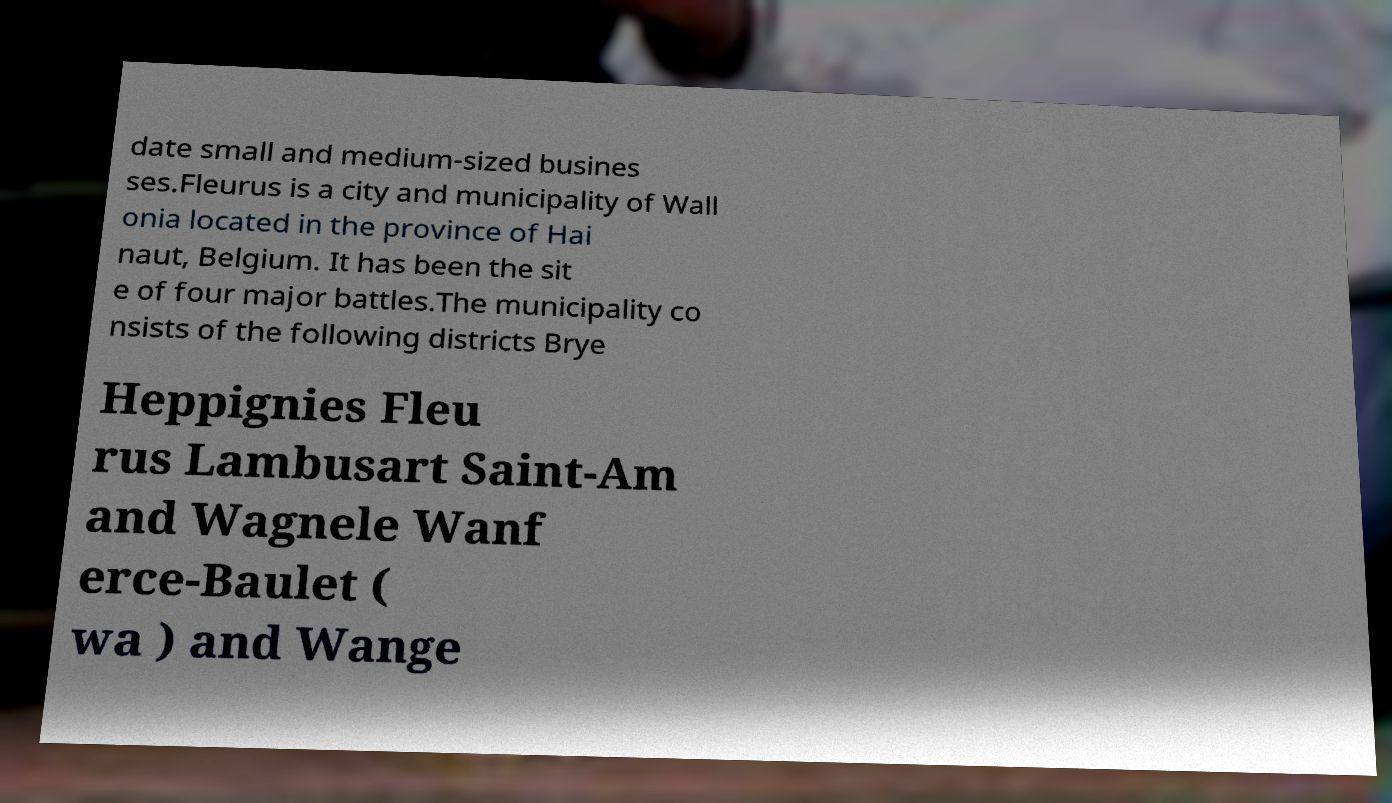Can you read and provide the text displayed in the image?This photo seems to have some interesting text. Can you extract and type it out for me? date small and medium-sized busines ses.Fleurus is a city and municipality of Wall onia located in the province of Hai naut, Belgium. It has been the sit e of four major battles.The municipality co nsists of the following districts Brye Heppignies Fleu rus Lambusart Saint-Am and Wagnele Wanf erce-Baulet ( wa ) and Wange 